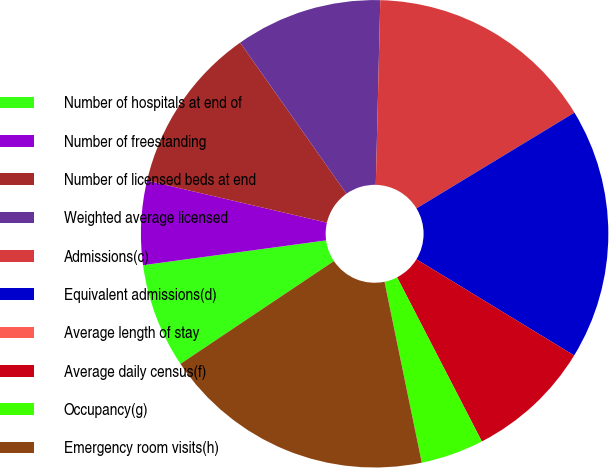<chart> <loc_0><loc_0><loc_500><loc_500><pie_chart><fcel>Number of hospitals at end of<fcel>Number of freestanding<fcel>Number of licensed beds at end<fcel>Weighted average licensed<fcel>Admissions(c)<fcel>Equivalent admissions(d)<fcel>Average length of stay<fcel>Average daily census(f)<fcel>Occupancy(g)<fcel>Emergency room visits(h)<nl><fcel>7.25%<fcel>5.8%<fcel>11.59%<fcel>10.14%<fcel>15.94%<fcel>17.39%<fcel>0.0%<fcel>8.7%<fcel>4.35%<fcel>18.84%<nl></chart> 